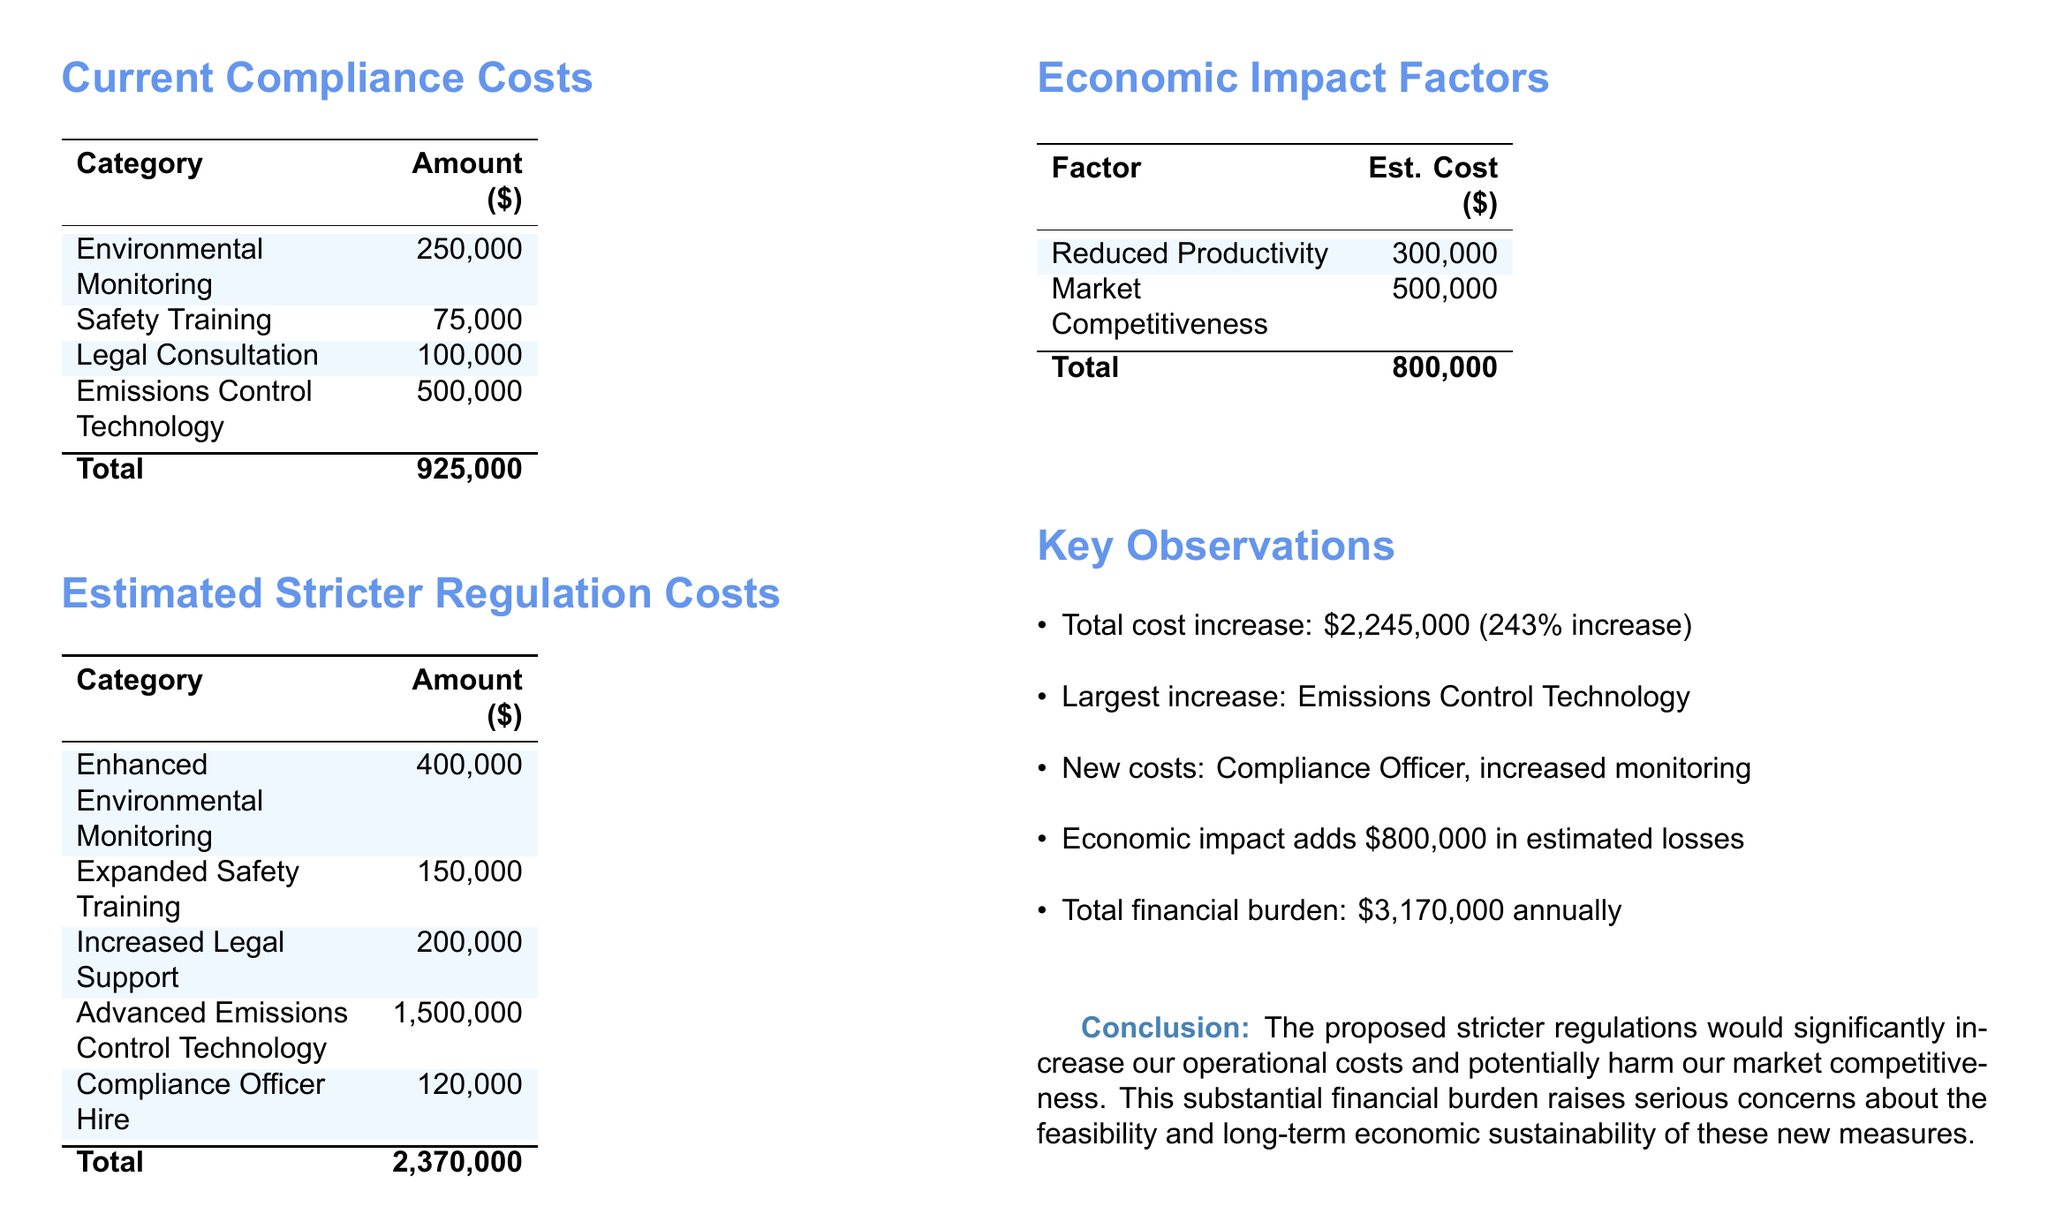What is the total amount of current compliance costs? The total current compliance costs are listed at the bottom of the corresponding table in the document, aggregating all the specified amounts.
Answer: 925,000 What is the estimated cost for enhanced environmental monitoring? The document provides a specific amount for this category under the stricter regulation cost section.
Answer: 400,000 What is the percentage increase in total cost under stricter regulations? The document explicitly states the percentage increase in total costs when comparing current compliance costs and stricter regulation costs.
Answer: 243% What is the largest cost increase category? The key observations section notes which category has the most significant increase in costs when moving to stricter regulations.
Answer: Emissions Control Technology What is the estimated economic impact from reduced productivity? The economic impact factor table lists the cost associated with reduced productivity specifically.
Answer: 300,000 How much would hiring a compliance officer cost? The estimated stricter regulation costs section indicates this specific cost for hiring a compliance officer.
Answer: 120,000 What is the total financial burden annually under stricter regulations? The document sums all costs, including current compliance costs, stricter regulation costs, and economic impacts, to present the total financial burden.
Answer: 3,170,000 What is the additional cost associated with market competitiveness? The economic impact factors table includes the estimated cost for maintaining market competitiveness.
Answer: 500,000 What amount is allocated for expanded safety training under stricter regulations? The table under estimated stricter regulation costs specifically lists how much is budgeted for expanded safety training.
Answer: 150,000 